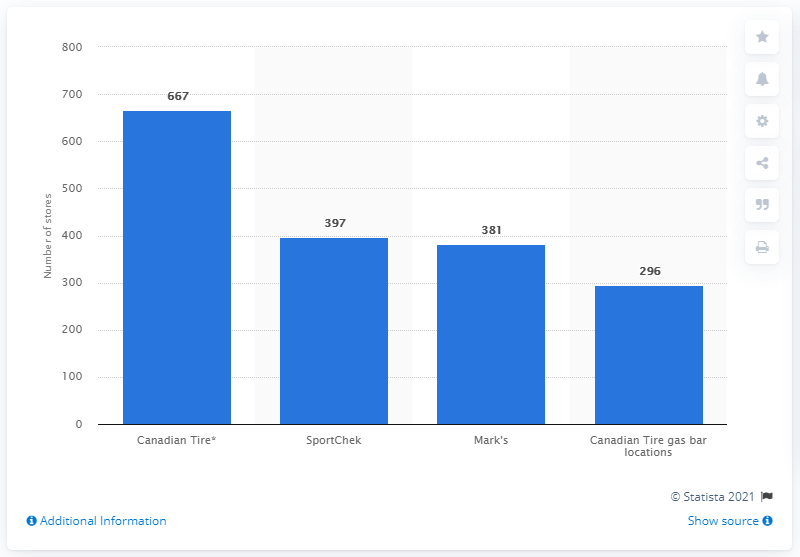Outline some significant characteristics in this image. In 2020, Canadian Tire operated 381 Mark's stores. 